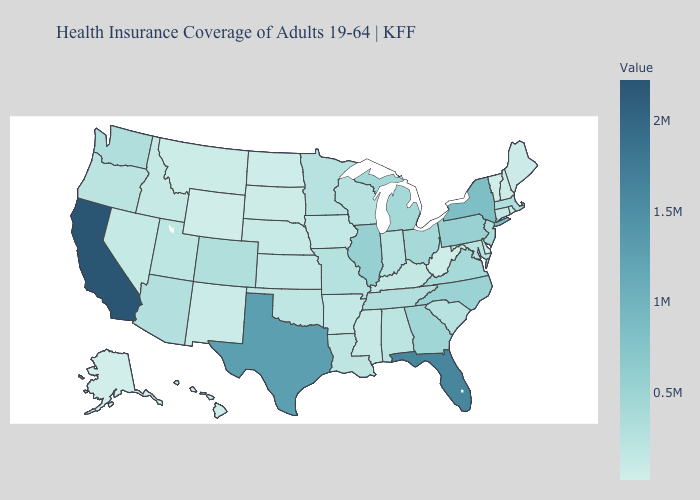Does Alaska have the lowest value in the USA?
Concise answer only. Yes. Does California have the highest value in the USA?
Concise answer only. Yes. Among the states that border Massachusetts , which have the highest value?
Concise answer only. New York. Does Alaska have the lowest value in the USA?
Give a very brief answer. Yes. 